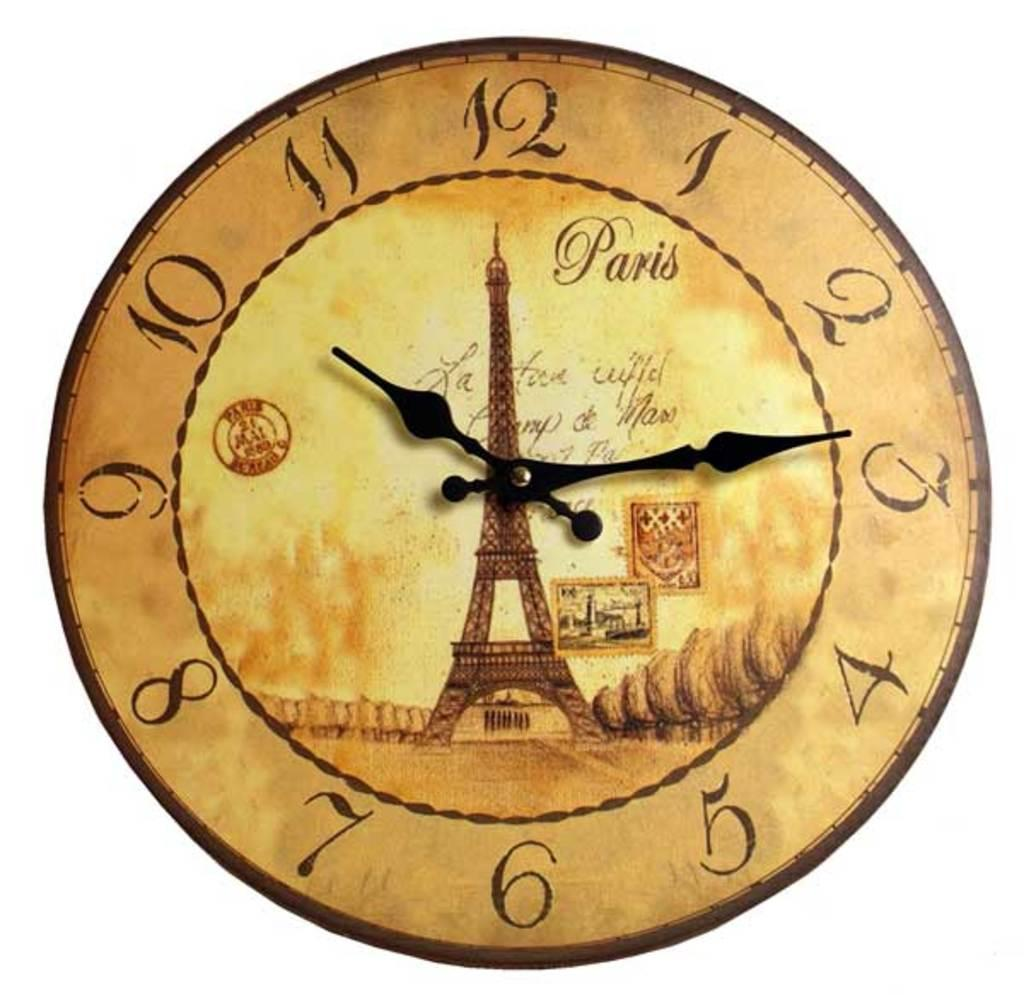<image>
Give a short and clear explanation of the subsequent image. A faded clock face has the Eiffel tower on it and says Paris. 